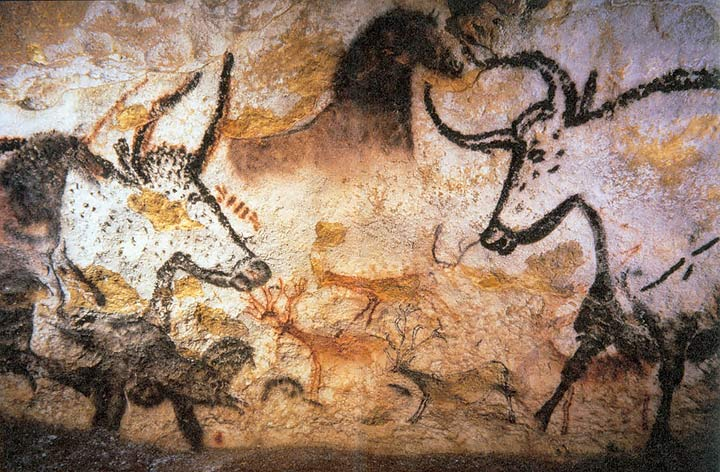What techniques did prehistoric artists use to create these paintings? Prehistoric artists used natural pigments, primarily consisting of minerals like ochre, charcoal, and hematite. They applied these pigments with their fingers, brushes made from animal hair, or directly by blowing pigment onto the wall. Interestingly, the depth and shade variations suggest they used techniques such as stenciling and dabbing to achieve dynamic effects. 